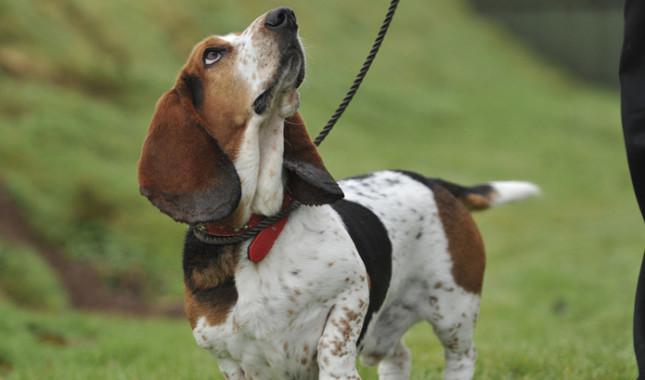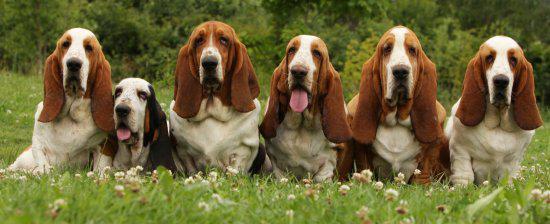The first image is the image on the left, the second image is the image on the right. Analyze the images presented: Is the assertion "An image shows at least one camera-facing basset hound sitting upright in the grass." valid? Answer yes or no. Yes. The first image is the image on the left, the second image is the image on the right. Given the left and right images, does the statement "There are at least three dogs outside in the grass." hold true? Answer yes or no. Yes. 